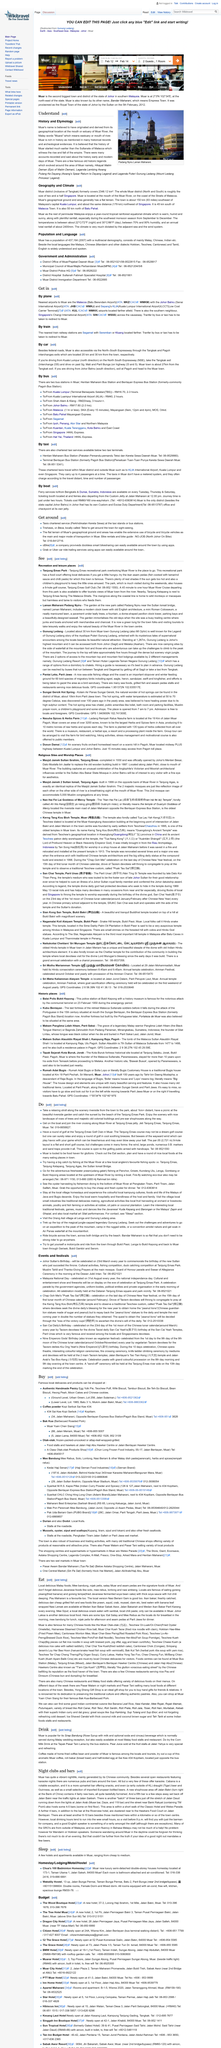Mention a couple of crucial points in this snapshot. The history of Muar is believed to have started much earlier than the Sultanate of Malacca. In the Malay language, the word 'Muara' refers to the estuary or mouth of a river. The above picture portrays the Padang Nyiru Laman Maharani, which is a place of interest in Indonesia. 